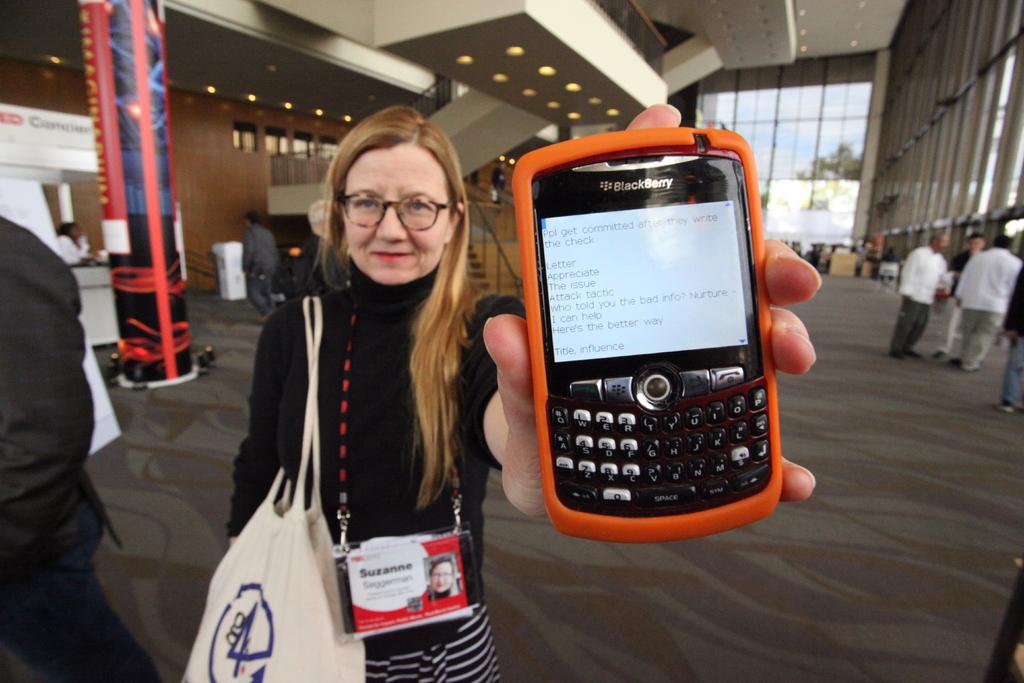What brand of phone is this?
Your response must be concise. Blackberry. What number is on the lady's bag?
Provide a short and direct response. 4. 